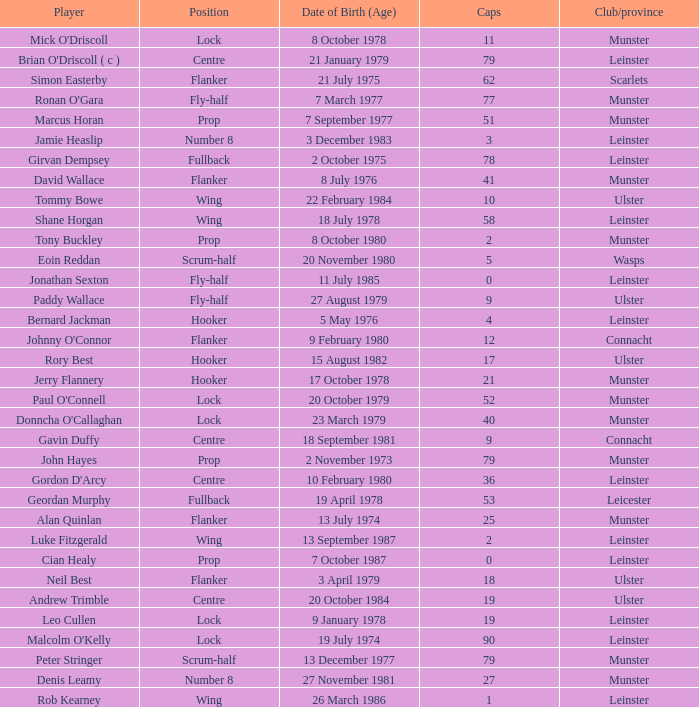What is the total of Caps when player born 13 December 1977? 79.0. 